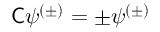Convert formula to latex. <formula><loc_0><loc_0><loc_500><loc_500>{ C } \psi ^ { ( \pm ) } = \pm \psi ^ { ( \pm ) }</formula> 